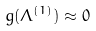Convert formula to latex. <formula><loc_0><loc_0><loc_500><loc_500>g ( \Lambda ^ { ( 1 ) } ) \approx 0</formula> 